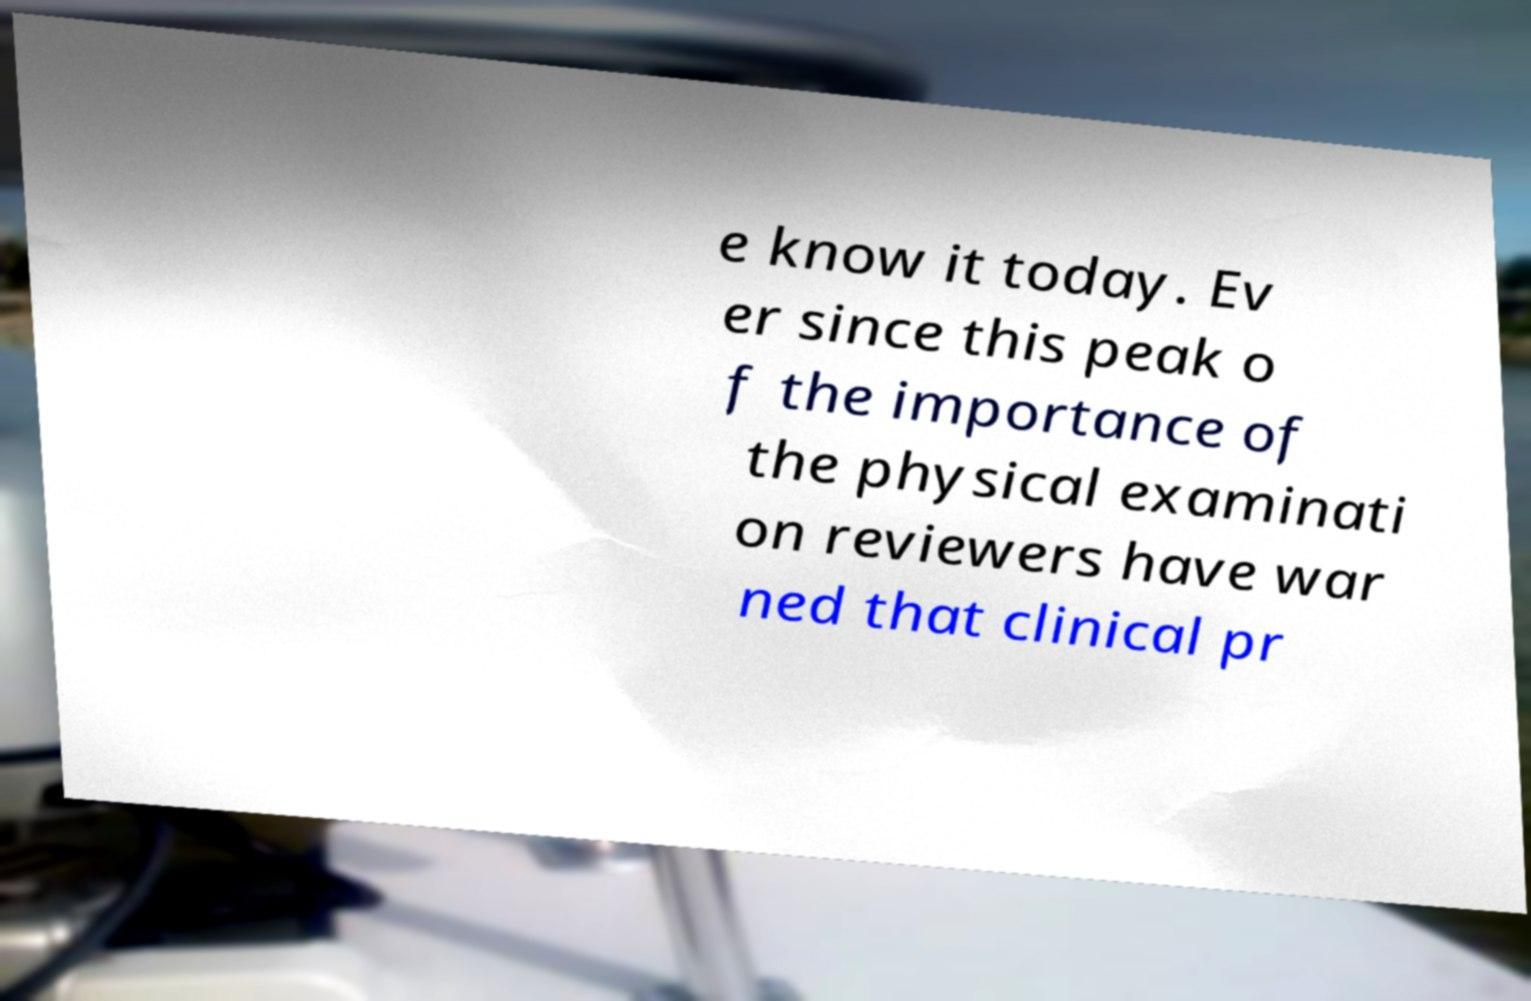Could you extract and type out the text from this image? e know it today. Ev er since this peak o f the importance of the physical examinati on reviewers have war ned that clinical pr 